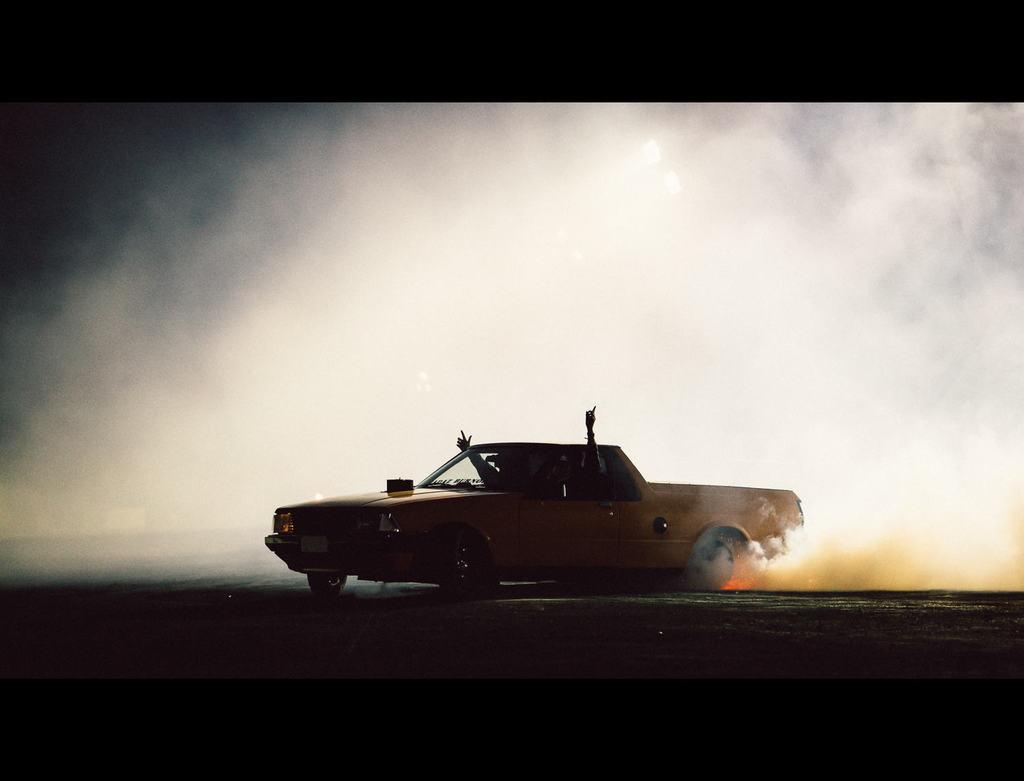What color is the vehicle in the image? The vehicle in the image is yellow. What else can be seen in the image besides the vehicle? Smoke is visible in the image. Can you identify any human elements in the image? Yes, two hands of people are present in the image. Where is the icicle hanging in the image? There is no icicle present in the image. What type of destruction can be seen in the image? There is no destruction present in the image. 